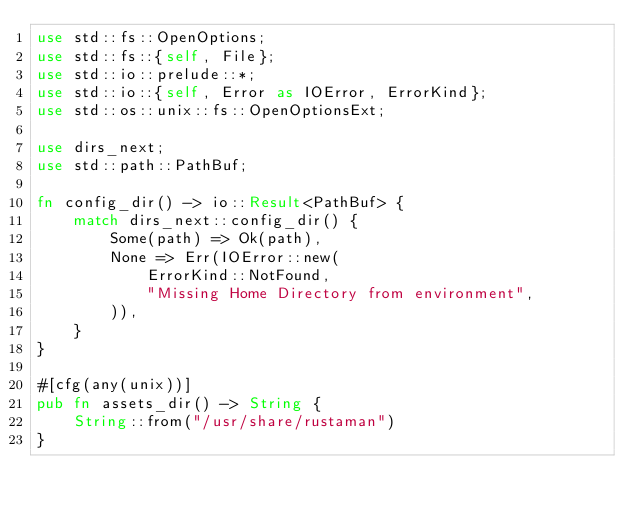<code> <loc_0><loc_0><loc_500><loc_500><_Rust_>use std::fs::OpenOptions;
use std::fs::{self, File};
use std::io::prelude::*;
use std::io::{self, Error as IOError, ErrorKind};
use std::os::unix::fs::OpenOptionsExt;

use dirs_next;
use std::path::PathBuf;

fn config_dir() -> io::Result<PathBuf> {
    match dirs_next::config_dir() {
        Some(path) => Ok(path),
        None => Err(IOError::new(
            ErrorKind::NotFound,
            "Missing Home Directory from environment",
        )),
    }
}

#[cfg(any(unix))]
pub fn assets_dir() -> String {
    String::from("/usr/share/rustaman")
}
</code> 